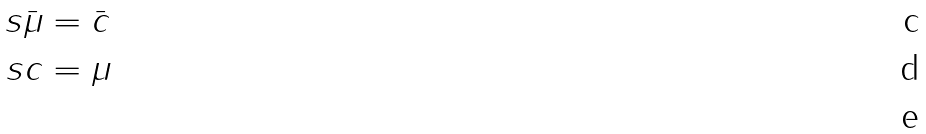Convert formula to latex. <formula><loc_0><loc_0><loc_500><loc_500>\ s \bar { \mu } & = \bar { c } \\ \ s c & = \mu \\</formula> 